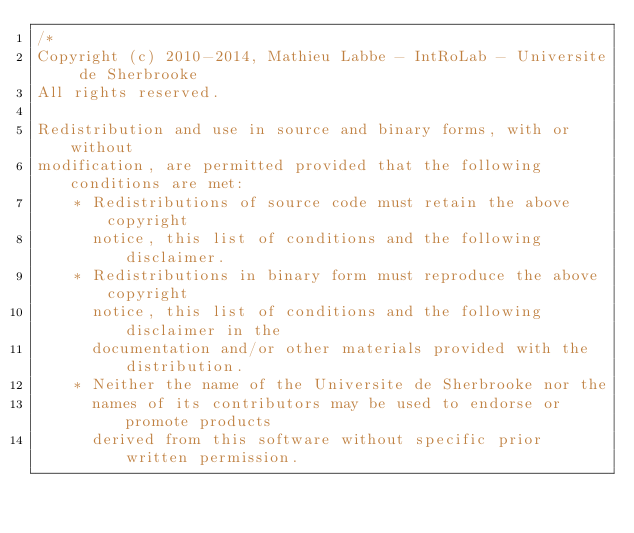Convert code to text. <code><loc_0><loc_0><loc_500><loc_500><_C++_>/*
Copyright (c) 2010-2014, Mathieu Labbe - IntRoLab - Universite de Sherbrooke
All rights reserved.

Redistribution and use in source and binary forms, with or without
modification, are permitted provided that the following conditions are met:
    * Redistributions of source code must retain the above copyright
      notice, this list of conditions and the following disclaimer.
    * Redistributions in binary form must reproduce the above copyright
      notice, this list of conditions and the following disclaimer in the
      documentation and/or other materials provided with the distribution.
    * Neither the name of the Universite de Sherbrooke nor the
      names of its contributors may be used to endorse or promote products
      derived from this software without specific prior written permission.
</code> 